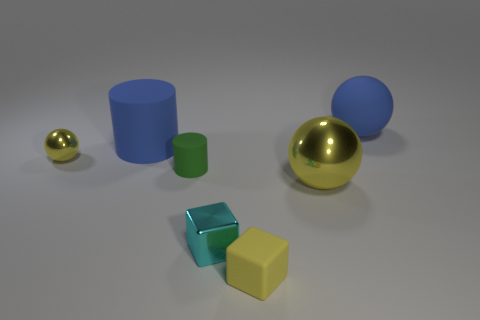Is the color of the tiny ball the same as the small matte cube?
Give a very brief answer. Yes. How many big blue objects are both to the right of the large blue rubber cylinder and on the left side of the blue sphere?
Provide a succinct answer. 0. The blue rubber thing to the left of the blue sphere has what shape?
Provide a short and direct response. Cylinder. Is the number of blue balls left of the green object less than the number of small matte cubes on the right side of the rubber ball?
Ensure brevity in your answer.  No. Is the tiny yellow object to the left of the green cylinder made of the same material as the blue thing that is to the left of the large blue ball?
Provide a short and direct response. No. There is a cyan metallic thing; what shape is it?
Ensure brevity in your answer.  Cube. Is the number of small green matte cylinders that are behind the yellow rubber block greater than the number of cyan metallic blocks right of the shiny block?
Give a very brief answer. Yes. Is the shape of the big blue object left of the blue sphere the same as the blue thing that is to the right of the matte cube?
Keep it short and to the point. No. What number of other objects are the same size as the blue sphere?
Offer a very short reply. 2. What size is the rubber sphere?
Give a very brief answer. Large. 